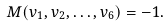Convert formula to latex. <formula><loc_0><loc_0><loc_500><loc_500>M ( v _ { 1 } , v _ { 2 } , \dots , v _ { 6 } ) = - 1 .</formula> 